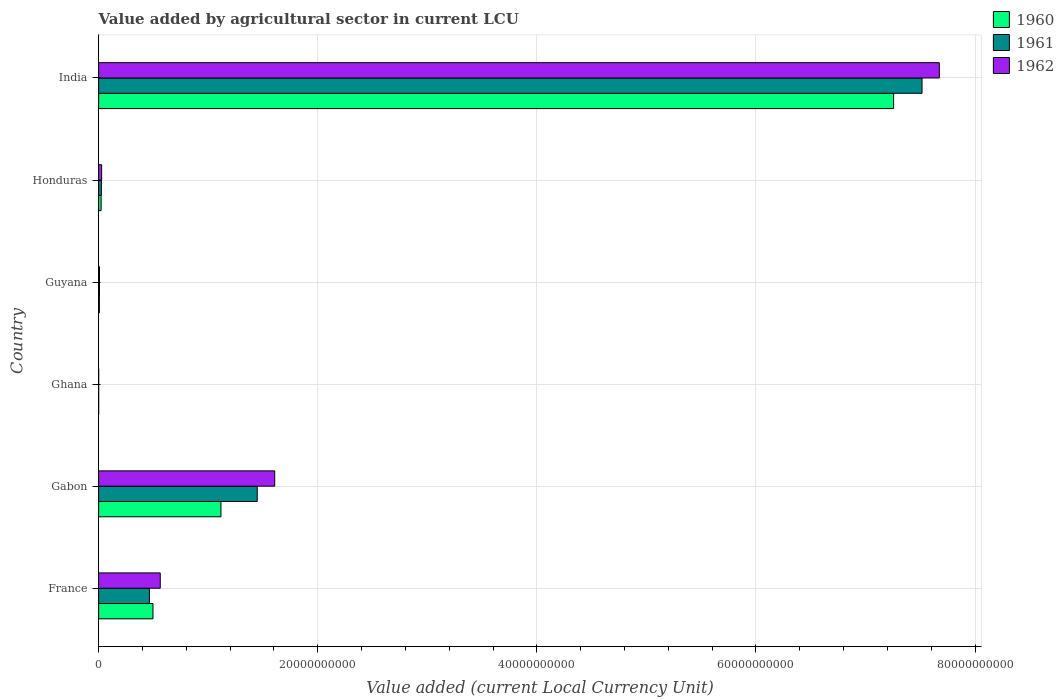How many different coloured bars are there?
Make the answer very short. 3. Are the number of bars per tick equal to the number of legend labels?
Offer a very short reply. Yes. How many bars are there on the 5th tick from the top?
Make the answer very short. 3. What is the label of the 4th group of bars from the top?
Ensure brevity in your answer.  Ghana. What is the value added by agricultural sector in 1962 in France?
Provide a short and direct response. 5.62e+09. Across all countries, what is the maximum value added by agricultural sector in 1961?
Your response must be concise. 7.52e+1. Across all countries, what is the minimum value added by agricultural sector in 1962?
Provide a short and direct response. 3.74e+04. In which country was the value added by agricultural sector in 1961 maximum?
Provide a short and direct response. India. What is the total value added by agricultural sector in 1961 in the graph?
Offer a very short reply. 9.46e+1. What is the difference between the value added by agricultural sector in 1961 in Guyana and that in India?
Make the answer very short. -7.51e+1. What is the difference between the value added by agricultural sector in 1960 in Guyana and the value added by agricultural sector in 1961 in Honduras?
Provide a succinct answer. -1.82e+08. What is the average value added by agricultural sector in 1961 per country?
Offer a very short reply. 1.58e+1. What is the difference between the value added by agricultural sector in 1960 and value added by agricultural sector in 1962 in Guyana?
Your response must be concise. -9.60e+06. In how many countries, is the value added by agricultural sector in 1962 greater than 8000000000 LCU?
Offer a terse response. 2. What is the ratio of the value added by agricultural sector in 1960 in France to that in Ghana?
Your answer should be very brief. 1.40e+05. What is the difference between the highest and the second highest value added by agricultural sector in 1962?
Keep it short and to the point. 6.07e+1. What is the difference between the highest and the lowest value added by agricultural sector in 1960?
Offer a terse response. 7.26e+1. In how many countries, is the value added by agricultural sector in 1960 greater than the average value added by agricultural sector in 1960 taken over all countries?
Provide a short and direct response. 1. Is the sum of the value added by agricultural sector in 1961 in Guyana and Honduras greater than the maximum value added by agricultural sector in 1960 across all countries?
Provide a short and direct response. No. How many countries are there in the graph?
Your response must be concise. 6. Does the graph contain any zero values?
Provide a succinct answer. No. Where does the legend appear in the graph?
Keep it short and to the point. Top right. How many legend labels are there?
Your answer should be compact. 3. What is the title of the graph?
Ensure brevity in your answer.  Value added by agricultural sector in current LCU. What is the label or title of the X-axis?
Keep it short and to the point. Value added (current Local Currency Unit). What is the label or title of the Y-axis?
Your response must be concise. Country. What is the Value added (current Local Currency Unit) of 1960 in France?
Your answer should be compact. 4.96e+09. What is the Value added (current Local Currency Unit) of 1961 in France?
Provide a succinct answer. 4.63e+09. What is the Value added (current Local Currency Unit) in 1962 in France?
Provide a succinct answer. 5.62e+09. What is the Value added (current Local Currency Unit) in 1960 in Gabon?
Your answer should be compact. 1.12e+1. What is the Value added (current Local Currency Unit) of 1961 in Gabon?
Provide a short and direct response. 1.45e+1. What is the Value added (current Local Currency Unit) in 1962 in Gabon?
Your response must be concise. 1.61e+1. What is the Value added (current Local Currency Unit) in 1960 in Ghana?
Your answer should be very brief. 3.55e+04. What is the Value added (current Local Currency Unit) of 1961 in Ghana?
Your answer should be compact. 3.29e+04. What is the Value added (current Local Currency Unit) of 1962 in Ghana?
Ensure brevity in your answer.  3.74e+04. What is the Value added (current Local Currency Unit) of 1960 in Guyana?
Offer a terse response. 6.88e+07. What is the Value added (current Local Currency Unit) of 1961 in Guyana?
Your answer should be very brief. 7.60e+07. What is the Value added (current Local Currency Unit) in 1962 in Guyana?
Your response must be concise. 7.84e+07. What is the Value added (current Local Currency Unit) in 1960 in Honduras?
Offer a terse response. 2.27e+08. What is the Value added (current Local Currency Unit) of 1961 in Honduras?
Offer a very short reply. 2.51e+08. What is the Value added (current Local Currency Unit) of 1962 in Honduras?
Your response must be concise. 2.74e+08. What is the Value added (current Local Currency Unit) in 1960 in India?
Your answer should be compact. 7.26e+1. What is the Value added (current Local Currency Unit) in 1961 in India?
Provide a succinct answer. 7.52e+1. What is the Value added (current Local Currency Unit) in 1962 in India?
Your answer should be very brief. 7.67e+1. Across all countries, what is the maximum Value added (current Local Currency Unit) of 1960?
Your answer should be very brief. 7.26e+1. Across all countries, what is the maximum Value added (current Local Currency Unit) of 1961?
Give a very brief answer. 7.52e+1. Across all countries, what is the maximum Value added (current Local Currency Unit) of 1962?
Ensure brevity in your answer.  7.67e+1. Across all countries, what is the minimum Value added (current Local Currency Unit) of 1960?
Offer a very short reply. 3.55e+04. Across all countries, what is the minimum Value added (current Local Currency Unit) of 1961?
Give a very brief answer. 3.29e+04. Across all countries, what is the minimum Value added (current Local Currency Unit) of 1962?
Your answer should be very brief. 3.74e+04. What is the total Value added (current Local Currency Unit) of 1960 in the graph?
Provide a short and direct response. 8.90e+1. What is the total Value added (current Local Currency Unit) in 1961 in the graph?
Your answer should be compact. 9.46e+1. What is the total Value added (current Local Currency Unit) in 1962 in the graph?
Ensure brevity in your answer.  9.88e+1. What is the difference between the Value added (current Local Currency Unit) in 1960 in France and that in Gabon?
Give a very brief answer. -6.20e+09. What is the difference between the Value added (current Local Currency Unit) of 1961 in France and that in Gabon?
Provide a succinct answer. -9.84e+09. What is the difference between the Value added (current Local Currency Unit) of 1962 in France and that in Gabon?
Your answer should be compact. -1.04e+1. What is the difference between the Value added (current Local Currency Unit) in 1960 in France and that in Ghana?
Give a very brief answer. 4.96e+09. What is the difference between the Value added (current Local Currency Unit) of 1961 in France and that in Ghana?
Provide a short and direct response. 4.63e+09. What is the difference between the Value added (current Local Currency Unit) in 1962 in France and that in Ghana?
Offer a very short reply. 5.62e+09. What is the difference between the Value added (current Local Currency Unit) of 1960 in France and that in Guyana?
Your response must be concise. 4.89e+09. What is the difference between the Value added (current Local Currency Unit) of 1961 in France and that in Guyana?
Provide a short and direct response. 4.56e+09. What is the difference between the Value added (current Local Currency Unit) of 1962 in France and that in Guyana?
Make the answer very short. 5.55e+09. What is the difference between the Value added (current Local Currency Unit) of 1960 in France and that in Honduras?
Your response must be concise. 4.73e+09. What is the difference between the Value added (current Local Currency Unit) of 1961 in France and that in Honduras?
Provide a short and direct response. 4.38e+09. What is the difference between the Value added (current Local Currency Unit) of 1962 in France and that in Honduras?
Provide a short and direct response. 5.35e+09. What is the difference between the Value added (current Local Currency Unit) in 1960 in France and that in India?
Your response must be concise. -6.76e+1. What is the difference between the Value added (current Local Currency Unit) of 1961 in France and that in India?
Offer a terse response. -7.05e+1. What is the difference between the Value added (current Local Currency Unit) of 1962 in France and that in India?
Make the answer very short. -7.11e+1. What is the difference between the Value added (current Local Currency Unit) in 1960 in Gabon and that in Ghana?
Ensure brevity in your answer.  1.12e+1. What is the difference between the Value added (current Local Currency Unit) of 1961 in Gabon and that in Ghana?
Your answer should be very brief. 1.45e+1. What is the difference between the Value added (current Local Currency Unit) in 1962 in Gabon and that in Ghana?
Make the answer very short. 1.61e+1. What is the difference between the Value added (current Local Currency Unit) in 1960 in Gabon and that in Guyana?
Your response must be concise. 1.11e+1. What is the difference between the Value added (current Local Currency Unit) of 1961 in Gabon and that in Guyana?
Make the answer very short. 1.44e+1. What is the difference between the Value added (current Local Currency Unit) of 1962 in Gabon and that in Guyana?
Provide a short and direct response. 1.60e+1. What is the difference between the Value added (current Local Currency Unit) of 1960 in Gabon and that in Honduras?
Ensure brevity in your answer.  1.09e+1. What is the difference between the Value added (current Local Currency Unit) of 1961 in Gabon and that in Honduras?
Offer a very short reply. 1.42e+1. What is the difference between the Value added (current Local Currency Unit) of 1962 in Gabon and that in Honduras?
Provide a short and direct response. 1.58e+1. What is the difference between the Value added (current Local Currency Unit) of 1960 in Gabon and that in India?
Ensure brevity in your answer.  -6.14e+1. What is the difference between the Value added (current Local Currency Unit) of 1961 in Gabon and that in India?
Give a very brief answer. -6.07e+1. What is the difference between the Value added (current Local Currency Unit) of 1962 in Gabon and that in India?
Make the answer very short. -6.07e+1. What is the difference between the Value added (current Local Currency Unit) of 1960 in Ghana and that in Guyana?
Your answer should be very brief. -6.88e+07. What is the difference between the Value added (current Local Currency Unit) of 1961 in Ghana and that in Guyana?
Give a very brief answer. -7.60e+07. What is the difference between the Value added (current Local Currency Unit) of 1962 in Ghana and that in Guyana?
Offer a terse response. -7.84e+07. What is the difference between the Value added (current Local Currency Unit) of 1960 in Ghana and that in Honduras?
Your response must be concise. -2.27e+08. What is the difference between the Value added (current Local Currency Unit) in 1961 in Ghana and that in Honduras?
Provide a short and direct response. -2.51e+08. What is the difference between the Value added (current Local Currency Unit) of 1962 in Ghana and that in Honduras?
Keep it short and to the point. -2.74e+08. What is the difference between the Value added (current Local Currency Unit) in 1960 in Ghana and that in India?
Ensure brevity in your answer.  -7.26e+1. What is the difference between the Value added (current Local Currency Unit) of 1961 in Ghana and that in India?
Your answer should be compact. -7.52e+1. What is the difference between the Value added (current Local Currency Unit) in 1962 in Ghana and that in India?
Keep it short and to the point. -7.67e+1. What is the difference between the Value added (current Local Currency Unit) of 1960 in Guyana and that in Honduras?
Give a very brief answer. -1.58e+08. What is the difference between the Value added (current Local Currency Unit) of 1961 in Guyana and that in Honduras?
Keep it short and to the point. -1.75e+08. What is the difference between the Value added (current Local Currency Unit) of 1962 in Guyana and that in Honduras?
Keep it short and to the point. -1.96e+08. What is the difference between the Value added (current Local Currency Unit) in 1960 in Guyana and that in India?
Your answer should be compact. -7.25e+1. What is the difference between the Value added (current Local Currency Unit) in 1961 in Guyana and that in India?
Your response must be concise. -7.51e+1. What is the difference between the Value added (current Local Currency Unit) in 1962 in Guyana and that in India?
Ensure brevity in your answer.  -7.67e+1. What is the difference between the Value added (current Local Currency Unit) of 1960 in Honduras and that in India?
Your answer should be very brief. -7.23e+1. What is the difference between the Value added (current Local Currency Unit) in 1961 in Honduras and that in India?
Ensure brevity in your answer.  -7.49e+1. What is the difference between the Value added (current Local Currency Unit) in 1962 in Honduras and that in India?
Your answer should be compact. -7.65e+1. What is the difference between the Value added (current Local Currency Unit) of 1960 in France and the Value added (current Local Currency Unit) of 1961 in Gabon?
Ensure brevity in your answer.  -9.52e+09. What is the difference between the Value added (current Local Currency Unit) of 1960 in France and the Value added (current Local Currency Unit) of 1962 in Gabon?
Make the answer very short. -1.11e+1. What is the difference between the Value added (current Local Currency Unit) in 1961 in France and the Value added (current Local Currency Unit) in 1962 in Gabon?
Provide a succinct answer. -1.14e+1. What is the difference between the Value added (current Local Currency Unit) of 1960 in France and the Value added (current Local Currency Unit) of 1961 in Ghana?
Keep it short and to the point. 4.96e+09. What is the difference between the Value added (current Local Currency Unit) of 1960 in France and the Value added (current Local Currency Unit) of 1962 in Ghana?
Provide a succinct answer. 4.96e+09. What is the difference between the Value added (current Local Currency Unit) of 1961 in France and the Value added (current Local Currency Unit) of 1962 in Ghana?
Your answer should be compact. 4.63e+09. What is the difference between the Value added (current Local Currency Unit) of 1960 in France and the Value added (current Local Currency Unit) of 1961 in Guyana?
Ensure brevity in your answer.  4.88e+09. What is the difference between the Value added (current Local Currency Unit) in 1960 in France and the Value added (current Local Currency Unit) in 1962 in Guyana?
Provide a short and direct response. 4.88e+09. What is the difference between the Value added (current Local Currency Unit) of 1961 in France and the Value added (current Local Currency Unit) of 1962 in Guyana?
Your answer should be very brief. 4.56e+09. What is the difference between the Value added (current Local Currency Unit) of 1960 in France and the Value added (current Local Currency Unit) of 1961 in Honduras?
Ensure brevity in your answer.  4.71e+09. What is the difference between the Value added (current Local Currency Unit) of 1960 in France and the Value added (current Local Currency Unit) of 1962 in Honduras?
Provide a succinct answer. 4.69e+09. What is the difference between the Value added (current Local Currency Unit) in 1961 in France and the Value added (current Local Currency Unit) in 1962 in Honduras?
Offer a very short reply. 4.36e+09. What is the difference between the Value added (current Local Currency Unit) of 1960 in France and the Value added (current Local Currency Unit) of 1961 in India?
Give a very brief answer. -7.02e+1. What is the difference between the Value added (current Local Currency Unit) in 1960 in France and the Value added (current Local Currency Unit) in 1962 in India?
Your response must be concise. -7.18e+1. What is the difference between the Value added (current Local Currency Unit) of 1961 in France and the Value added (current Local Currency Unit) of 1962 in India?
Your answer should be compact. -7.21e+1. What is the difference between the Value added (current Local Currency Unit) in 1960 in Gabon and the Value added (current Local Currency Unit) in 1961 in Ghana?
Offer a very short reply. 1.12e+1. What is the difference between the Value added (current Local Currency Unit) of 1960 in Gabon and the Value added (current Local Currency Unit) of 1962 in Ghana?
Provide a short and direct response. 1.12e+1. What is the difference between the Value added (current Local Currency Unit) of 1961 in Gabon and the Value added (current Local Currency Unit) of 1962 in Ghana?
Provide a short and direct response. 1.45e+1. What is the difference between the Value added (current Local Currency Unit) in 1960 in Gabon and the Value added (current Local Currency Unit) in 1961 in Guyana?
Keep it short and to the point. 1.11e+1. What is the difference between the Value added (current Local Currency Unit) of 1960 in Gabon and the Value added (current Local Currency Unit) of 1962 in Guyana?
Your answer should be very brief. 1.11e+1. What is the difference between the Value added (current Local Currency Unit) in 1961 in Gabon and the Value added (current Local Currency Unit) in 1962 in Guyana?
Keep it short and to the point. 1.44e+1. What is the difference between the Value added (current Local Currency Unit) of 1960 in Gabon and the Value added (current Local Currency Unit) of 1961 in Honduras?
Provide a short and direct response. 1.09e+1. What is the difference between the Value added (current Local Currency Unit) in 1960 in Gabon and the Value added (current Local Currency Unit) in 1962 in Honduras?
Keep it short and to the point. 1.09e+1. What is the difference between the Value added (current Local Currency Unit) of 1961 in Gabon and the Value added (current Local Currency Unit) of 1962 in Honduras?
Provide a short and direct response. 1.42e+1. What is the difference between the Value added (current Local Currency Unit) of 1960 in Gabon and the Value added (current Local Currency Unit) of 1961 in India?
Provide a succinct answer. -6.40e+1. What is the difference between the Value added (current Local Currency Unit) in 1960 in Gabon and the Value added (current Local Currency Unit) in 1962 in India?
Offer a terse response. -6.56e+1. What is the difference between the Value added (current Local Currency Unit) of 1961 in Gabon and the Value added (current Local Currency Unit) of 1962 in India?
Offer a very short reply. -6.23e+1. What is the difference between the Value added (current Local Currency Unit) in 1960 in Ghana and the Value added (current Local Currency Unit) in 1961 in Guyana?
Ensure brevity in your answer.  -7.60e+07. What is the difference between the Value added (current Local Currency Unit) in 1960 in Ghana and the Value added (current Local Currency Unit) in 1962 in Guyana?
Offer a terse response. -7.84e+07. What is the difference between the Value added (current Local Currency Unit) in 1961 in Ghana and the Value added (current Local Currency Unit) in 1962 in Guyana?
Your answer should be very brief. -7.84e+07. What is the difference between the Value added (current Local Currency Unit) of 1960 in Ghana and the Value added (current Local Currency Unit) of 1961 in Honduras?
Make the answer very short. -2.51e+08. What is the difference between the Value added (current Local Currency Unit) in 1960 in Ghana and the Value added (current Local Currency Unit) in 1962 in Honduras?
Your response must be concise. -2.74e+08. What is the difference between the Value added (current Local Currency Unit) in 1961 in Ghana and the Value added (current Local Currency Unit) in 1962 in Honduras?
Offer a very short reply. -2.74e+08. What is the difference between the Value added (current Local Currency Unit) of 1960 in Ghana and the Value added (current Local Currency Unit) of 1961 in India?
Your answer should be compact. -7.52e+1. What is the difference between the Value added (current Local Currency Unit) in 1960 in Ghana and the Value added (current Local Currency Unit) in 1962 in India?
Give a very brief answer. -7.67e+1. What is the difference between the Value added (current Local Currency Unit) in 1961 in Ghana and the Value added (current Local Currency Unit) in 1962 in India?
Provide a succinct answer. -7.67e+1. What is the difference between the Value added (current Local Currency Unit) in 1960 in Guyana and the Value added (current Local Currency Unit) in 1961 in Honduras?
Your answer should be compact. -1.82e+08. What is the difference between the Value added (current Local Currency Unit) of 1960 in Guyana and the Value added (current Local Currency Unit) of 1962 in Honduras?
Your response must be concise. -2.06e+08. What is the difference between the Value added (current Local Currency Unit) in 1961 in Guyana and the Value added (current Local Currency Unit) in 1962 in Honduras?
Your response must be concise. -1.98e+08. What is the difference between the Value added (current Local Currency Unit) in 1960 in Guyana and the Value added (current Local Currency Unit) in 1961 in India?
Your answer should be very brief. -7.51e+1. What is the difference between the Value added (current Local Currency Unit) in 1960 in Guyana and the Value added (current Local Currency Unit) in 1962 in India?
Your answer should be compact. -7.67e+1. What is the difference between the Value added (current Local Currency Unit) in 1961 in Guyana and the Value added (current Local Currency Unit) in 1962 in India?
Give a very brief answer. -7.67e+1. What is the difference between the Value added (current Local Currency Unit) of 1960 in Honduras and the Value added (current Local Currency Unit) of 1961 in India?
Provide a succinct answer. -7.49e+1. What is the difference between the Value added (current Local Currency Unit) in 1960 in Honduras and the Value added (current Local Currency Unit) in 1962 in India?
Your answer should be compact. -7.65e+1. What is the difference between the Value added (current Local Currency Unit) in 1961 in Honduras and the Value added (current Local Currency Unit) in 1962 in India?
Offer a terse response. -7.65e+1. What is the average Value added (current Local Currency Unit) of 1960 per country?
Ensure brevity in your answer.  1.48e+1. What is the average Value added (current Local Currency Unit) of 1961 per country?
Your answer should be very brief. 1.58e+1. What is the average Value added (current Local Currency Unit) in 1962 per country?
Your answer should be very brief. 1.65e+1. What is the difference between the Value added (current Local Currency Unit) of 1960 and Value added (current Local Currency Unit) of 1961 in France?
Make the answer very short. 3.26e+08. What is the difference between the Value added (current Local Currency Unit) in 1960 and Value added (current Local Currency Unit) in 1962 in France?
Your answer should be very brief. -6.64e+08. What is the difference between the Value added (current Local Currency Unit) of 1961 and Value added (current Local Currency Unit) of 1962 in France?
Offer a very short reply. -9.90e+08. What is the difference between the Value added (current Local Currency Unit) in 1960 and Value added (current Local Currency Unit) in 1961 in Gabon?
Your response must be concise. -3.31e+09. What is the difference between the Value added (current Local Currency Unit) in 1960 and Value added (current Local Currency Unit) in 1962 in Gabon?
Offer a very short reply. -4.91e+09. What is the difference between the Value added (current Local Currency Unit) of 1961 and Value added (current Local Currency Unit) of 1962 in Gabon?
Provide a short and direct response. -1.59e+09. What is the difference between the Value added (current Local Currency Unit) in 1960 and Value added (current Local Currency Unit) in 1961 in Ghana?
Keep it short and to the point. 2600. What is the difference between the Value added (current Local Currency Unit) of 1960 and Value added (current Local Currency Unit) of 1962 in Ghana?
Your answer should be compact. -1900. What is the difference between the Value added (current Local Currency Unit) in 1961 and Value added (current Local Currency Unit) in 1962 in Ghana?
Offer a terse response. -4500. What is the difference between the Value added (current Local Currency Unit) of 1960 and Value added (current Local Currency Unit) of 1961 in Guyana?
Offer a terse response. -7.20e+06. What is the difference between the Value added (current Local Currency Unit) in 1960 and Value added (current Local Currency Unit) in 1962 in Guyana?
Keep it short and to the point. -9.60e+06. What is the difference between the Value added (current Local Currency Unit) in 1961 and Value added (current Local Currency Unit) in 1962 in Guyana?
Keep it short and to the point. -2.40e+06. What is the difference between the Value added (current Local Currency Unit) of 1960 and Value added (current Local Currency Unit) of 1961 in Honduras?
Provide a succinct answer. -2.42e+07. What is the difference between the Value added (current Local Currency Unit) of 1960 and Value added (current Local Currency Unit) of 1962 in Honduras?
Provide a short and direct response. -4.75e+07. What is the difference between the Value added (current Local Currency Unit) of 1961 and Value added (current Local Currency Unit) of 1962 in Honduras?
Give a very brief answer. -2.33e+07. What is the difference between the Value added (current Local Currency Unit) of 1960 and Value added (current Local Currency Unit) of 1961 in India?
Provide a short and direct response. -2.59e+09. What is the difference between the Value added (current Local Currency Unit) in 1960 and Value added (current Local Currency Unit) in 1962 in India?
Offer a terse response. -4.17e+09. What is the difference between the Value added (current Local Currency Unit) in 1961 and Value added (current Local Currency Unit) in 1962 in India?
Ensure brevity in your answer.  -1.58e+09. What is the ratio of the Value added (current Local Currency Unit) in 1960 in France to that in Gabon?
Your response must be concise. 0.44. What is the ratio of the Value added (current Local Currency Unit) in 1961 in France to that in Gabon?
Your answer should be very brief. 0.32. What is the ratio of the Value added (current Local Currency Unit) in 1962 in France to that in Gabon?
Your response must be concise. 0.35. What is the ratio of the Value added (current Local Currency Unit) of 1960 in France to that in Ghana?
Provide a short and direct response. 1.40e+05. What is the ratio of the Value added (current Local Currency Unit) in 1961 in France to that in Ghana?
Your answer should be compact. 1.41e+05. What is the ratio of the Value added (current Local Currency Unit) in 1962 in France to that in Ghana?
Your answer should be compact. 1.50e+05. What is the ratio of the Value added (current Local Currency Unit) of 1960 in France to that in Guyana?
Make the answer very short. 72.09. What is the ratio of the Value added (current Local Currency Unit) in 1961 in France to that in Guyana?
Keep it short and to the point. 60.97. What is the ratio of the Value added (current Local Currency Unit) of 1962 in France to that in Guyana?
Ensure brevity in your answer.  71.73. What is the ratio of the Value added (current Local Currency Unit) in 1960 in France to that in Honduras?
Ensure brevity in your answer.  21.85. What is the ratio of the Value added (current Local Currency Unit) of 1961 in France to that in Honduras?
Your answer should be very brief. 18.45. What is the ratio of the Value added (current Local Currency Unit) of 1962 in France to that in Honduras?
Provide a succinct answer. 20.49. What is the ratio of the Value added (current Local Currency Unit) of 1960 in France to that in India?
Your answer should be compact. 0.07. What is the ratio of the Value added (current Local Currency Unit) of 1961 in France to that in India?
Ensure brevity in your answer.  0.06. What is the ratio of the Value added (current Local Currency Unit) of 1962 in France to that in India?
Provide a short and direct response. 0.07. What is the ratio of the Value added (current Local Currency Unit) in 1960 in Gabon to that in Ghana?
Offer a very short reply. 3.14e+05. What is the ratio of the Value added (current Local Currency Unit) of 1961 in Gabon to that in Ghana?
Your response must be concise. 4.40e+05. What is the ratio of the Value added (current Local Currency Unit) in 1962 in Gabon to that in Ghana?
Your answer should be very brief. 4.30e+05. What is the ratio of the Value added (current Local Currency Unit) of 1960 in Gabon to that in Guyana?
Provide a succinct answer. 162.28. What is the ratio of the Value added (current Local Currency Unit) in 1961 in Gabon to that in Guyana?
Keep it short and to the point. 190.49. What is the ratio of the Value added (current Local Currency Unit) in 1962 in Gabon to that in Guyana?
Offer a terse response. 205. What is the ratio of the Value added (current Local Currency Unit) in 1960 in Gabon to that in Honduras?
Offer a terse response. 49.18. What is the ratio of the Value added (current Local Currency Unit) in 1961 in Gabon to that in Honduras?
Keep it short and to the point. 57.63. What is the ratio of the Value added (current Local Currency Unit) in 1962 in Gabon to that in Honduras?
Your answer should be very brief. 58.55. What is the ratio of the Value added (current Local Currency Unit) in 1960 in Gabon to that in India?
Make the answer very short. 0.15. What is the ratio of the Value added (current Local Currency Unit) of 1961 in Gabon to that in India?
Your response must be concise. 0.19. What is the ratio of the Value added (current Local Currency Unit) of 1962 in Gabon to that in India?
Give a very brief answer. 0.21. What is the ratio of the Value added (current Local Currency Unit) of 1962 in Ghana to that in Guyana?
Your response must be concise. 0. What is the ratio of the Value added (current Local Currency Unit) in 1960 in Ghana to that in Honduras?
Ensure brevity in your answer.  0. What is the ratio of the Value added (current Local Currency Unit) of 1962 in Ghana to that in Honduras?
Provide a short and direct response. 0. What is the ratio of the Value added (current Local Currency Unit) in 1961 in Ghana to that in India?
Keep it short and to the point. 0. What is the ratio of the Value added (current Local Currency Unit) of 1962 in Ghana to that in India?
Your answer should be compact. 0. What is the ratio of the Value added (current Local Currency Unit) of 1960 in Guyana to that in Honduras?
Keep it short and to the point. 0.3. What is the ratio of the Value added (current Local Currency Unit) in 1961 in Guyana to that in Honduras?
Give a very brief answer. 0.3. What is the ratio of the Value added (current Local Currency Unit) in 1962 in Guyana to that in Honduras?
Keep it short and to the point. 0.29. What is the ratio of the Value added (current Local Currency Unit) in 1960 in Guyana to that in India?
Offer a very short reply. 0. What is the ratio of the Value added (current Local Currency Unit) of 1962 in Guyana to that in India?
Provide a succinct answer. 0. What is the ratio of the Value added (current Local Currency Unit) of 1960 in Honduras to that in India?
Your answer should be compact. 0. What is the ratio of the Value added (current Local Currency Unit) of 1961 in Honduras to that in India?
Your response must be concise. 0. What is the ratio of the Value added (current Local Currency Unit) of 1962 in Honduras to that in India?
Your answer should be very brief. 0. What is the difference between the highest and the second highest Value added (current Local Currency Unit) of 1960?
Ensure brevity in your answer.  6.14e+1. What is the difference between the highest and the second highest Value added (current Local Currency Unit) of 1961?
Your answer should be very brief. 6.07e+1. What is the difference between the highest and the second highest Value added (current Local Currency Unit) of 1962?
Offer a terse response. 6.07e+1. What is the difference between the highest and the lowest Value added (current Local Currency Unit) in 1960?
Ensure brevity in your answer.  7.26e+1. What is the difference between the highest and the lowest Value added (current Local Currency Unit) in 1961?
Your answer should be very brief. 7.52e+1. What is the difference between the highest and the lowest Value added (current Local Currency Unit) of 1962?
Give a very brief answer. 7.67e+1. 